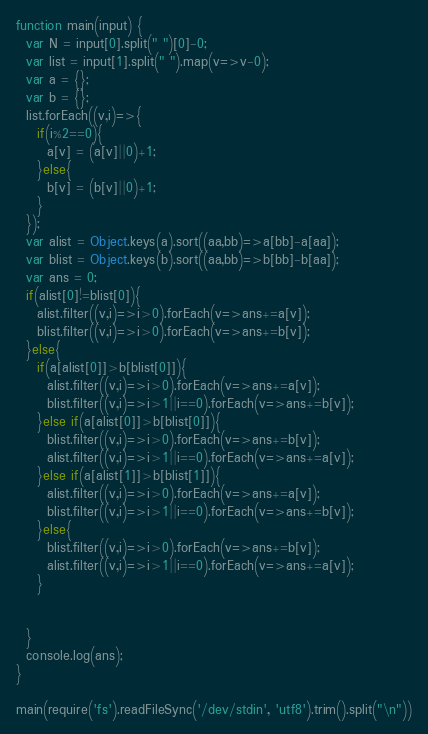<code> <loc_0><loc_0><loc_500><loc_500><_JavaScript_>function main(input) {
  var N = input[0].split(" ")[0]-0;
  var list = input[1].split(" ").map(v=>v-0);
  var a = {};
  var b = {};
  list.forEach((v,i)=>{
    if(i%2==0){
      a[v] = (a[v]||0)+1;
    }else{
      b[v] = (b[v]||0)+1;
    }
  });
  var alist = Object.keys(a).sort((aa,bb)=>a[bb]-a[aa]);
  var blist = Object.keys(b).sort((aa,bb)=>b[bb]-b[aa]);
  var ans = 0;
  if(alist[0]!=blist[0]){
    alist.filter((v,i)=>i>0).forEach(v=>ans+=a[v]);
    blist.filter((v,i)=>i>0).forEach(v=>ans+=b[v]);
  }else{
    if(a[alist[0]]>b[blist[0]]){
      alist.filter((v,i)=>i>0).forEach(v=>ans+=a[v]);
      blist.filter((v,i)=>i>1||i==0).forEach(v=>ans+=b[v]);
    }else if(a[alist[0]]>b[blist[0]]){
      blist.filter((v,i)=>i>0).forEach(v=>ans+=b[v]);
      alist.filter((v,i)=>i>1||i==0).forEach(v=>ans+=a[v]);
    }else if(a[alist[1]]>b[blist[1]]){
      alist.filter((v,i)=>i>0).forEach(v=>ans+=a[v]);
      blist.filter((v,i)=>i>1||i==0).forEach(v=>ans+=b[v]);
    }else{
      blist.filter((v,i)=>i>0).forEach(v=>ans+=b[v]);
      alist.filter((v,i)=>i>1||i==0).forEach(v=>ans+=a[v]);
    }
      
      
  }
  console.log(ans);
}

main(require('fs').readFileSync('/dev/stdin', 'utf8').trim().split("\n"))
</code> 